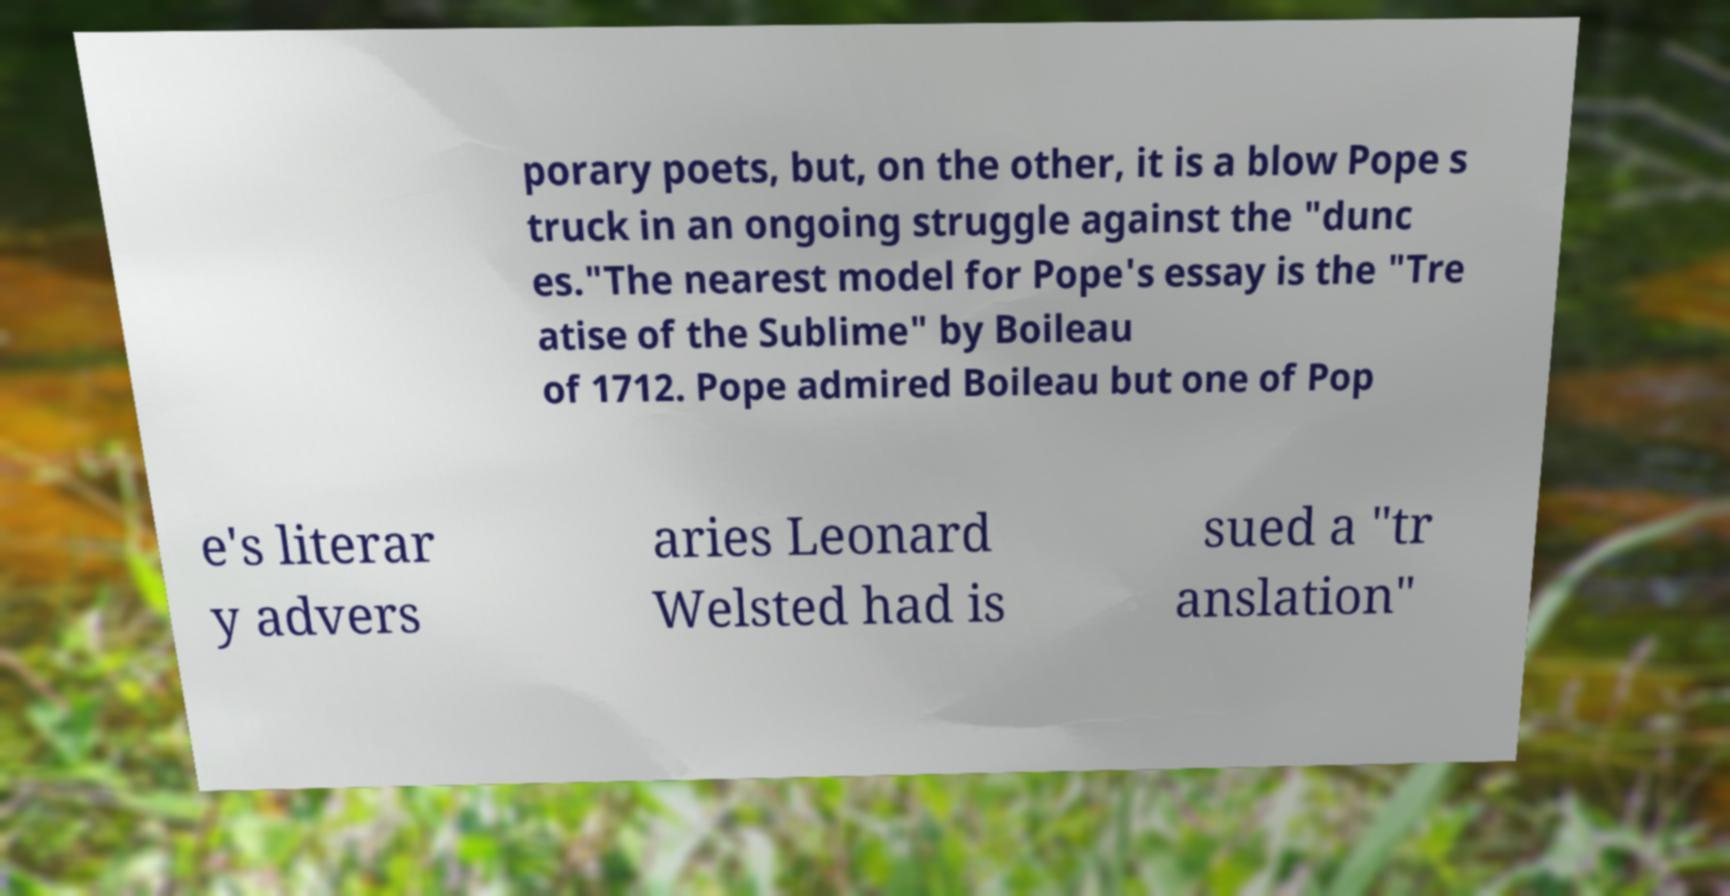Please read and relay the text visible in this image. What does it say? porary poets, but, on the other, it is a blow Pope s truck in an ongoing struggle against the "dunc es."The nearest model for Pope's essay is the "Tre atise of the Sublime" by Boileau of 1712. Pope admired Boileau but one of Pop e's literar y advers aries Leonard Welsted had is sued a "tr anslation" 